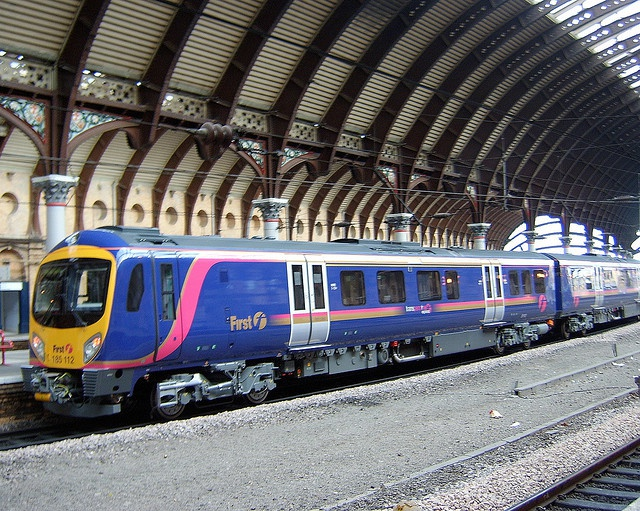Describe the objects in this image and their specific colors. I can see a train in black, blue, and gray tones in this image. 